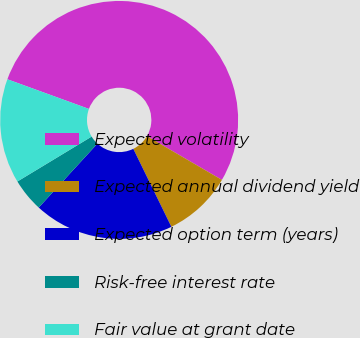Convert chart to OTSL. <chart><loc_0><loc_0><loc_500><loc_500><pie_chart><fcel>Expected volatility<fcel>Expected annual dividend yield<fcel>Expected option term (years)<fcel>Risk-free interest rate<fcel>Fair value at grant date<nl><fcel>52.86%<fcel>9.36%<fcel>19.05%<fcel>4.52%<fcel>14.21%<nl></chart> 